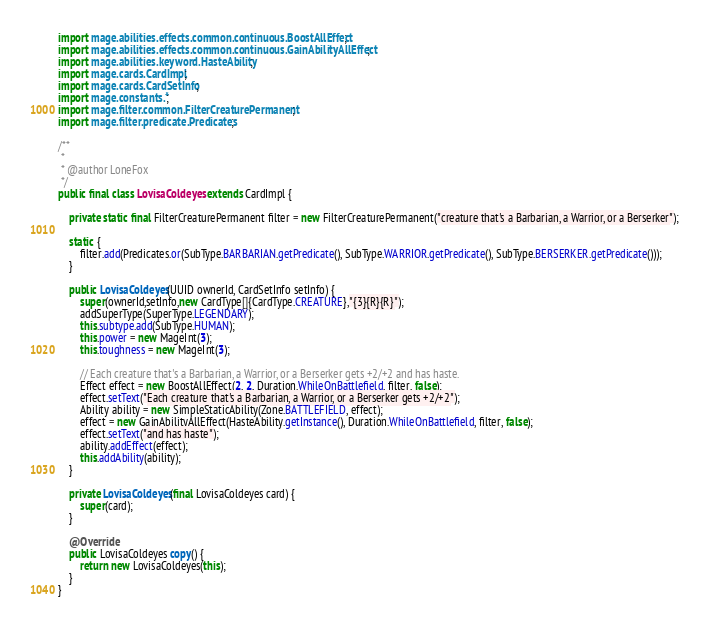Convert code to text. <code><loc_0><loc_0><loc_500><loc_500><_Java_>import mage.abilities.effects.common.continuous.BoostAllEffect;
import mage.abilities.effects.common.continuous.GainAbilityAllEffect;
import mage.abilities.keyword.HasteAbility;
import mage.cards.CardImpl;
import mage.cards.CardSetInfo;
import mage.constants.*;
import mage.filter.common.FilterCreaturePermanent;
import mage.filter.predicate.Predicates;

/**
 *
 * @author LoneFox
 */
public final class LovisaColdeyes extends CardImpl {

    private static final FilterCreaturePermanent filter = new FilterCreaturePermanent("creature that's a Barbarian, a Warrior, or a Berserker");

    static {
        filter.add(Predicates.or(SubType.BARBARIAN.getPredicate(), SubType.WARRIOR.getPredicate(), SubType.BERSERKER.getPredicate()));
    }

    public LovisaColdeyes(UUID ownerId, CardSetInfo setInfo) {
        super(ownerId,setInfo,new CardType[]{CardType.CREATURE},"{3}{R}{R}");
        addSuperType(SuperType.LEGENDARY);
        this.subtype.add(SubType.HUMAN);
        this.power = new MageInt(3);
        this.toughness = new MageInt(3);

        // Each creature that's a Barbarian, a Warrior, or a Berserker gets +2/+2 and has haste.
        Effect effect = new BoostAllEffect(2, 2, Duration.WhileOnBattlefield, filter, false);
        effect.setText("Each creature that's a Barbarian, a Warrior, or a Berserker gets +2/+2");
        Ability ability = new SimpleStaticAbility(Zone.BATTLEFIELD, effect);
        effect = new GainAbilityAllEffect(HasteAbility.getInstance(), Duration.WhileOnBattlefield, filter, false);
        effect.setText("and has haste");
        ability.addEffect(effect);
        this.addAbility(ability);
    }

    private LovisaColdeyes(final LovisaColdeyes card) {
        super(card);
    }

    @Override
    public LovisaColdeyes copy() {
        return new LovisaColdeyes(this);
    }
}
</code> 